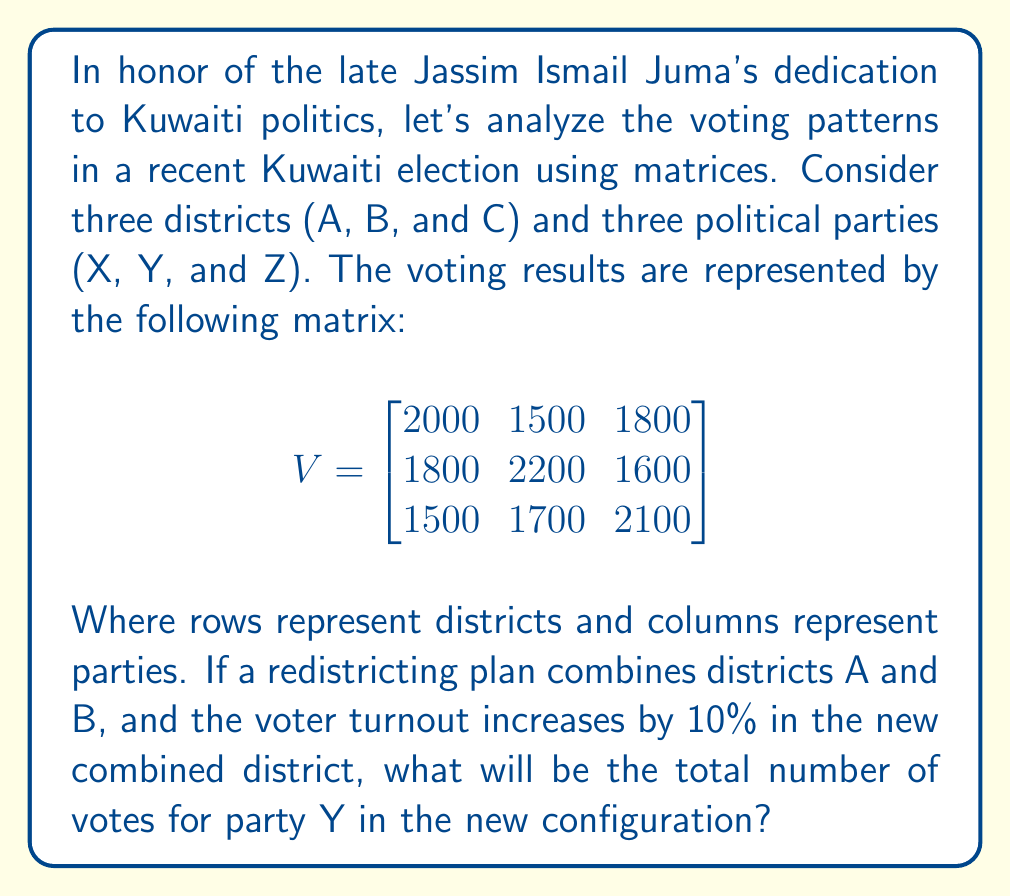Provide a solution to this math problem. Let's approach this step-by-step:

1) First, we need to combine the votes for districts A and B for each party:

   Party X: $2000 + 1800 = 3800$
   Party Y: $1500 + 2200 = 3700$
   Party Z: $1800 + 1600 = 3400$

2) Now, we need to increase these numbers by 10% due to the increased turnout:

   Party X: $3800 \times 1.10 = 4180$
   Party Y: $3700 \times 1.10 = 4070$
   Party Z: $3400 \times 1.10 = 3740$

3) The new voting matrix will look like this:

   $$
   V_{new} = \begin{bmatrix}
   4180 & 4070 & 3740 \\
   1500 & 1700 & 2100
   \end{bmatrix}
   $$

4) The question asks specifically about party Y in the new configuration. This is represented by the second column of the new matrix.

5) The total votes for party Y is the sum of the elements in this column:

   $4070 + 1700 = 5770$

Therefore, the total number of votes for party Y in the new configuration is 5770.
Answer: 5770 votes 